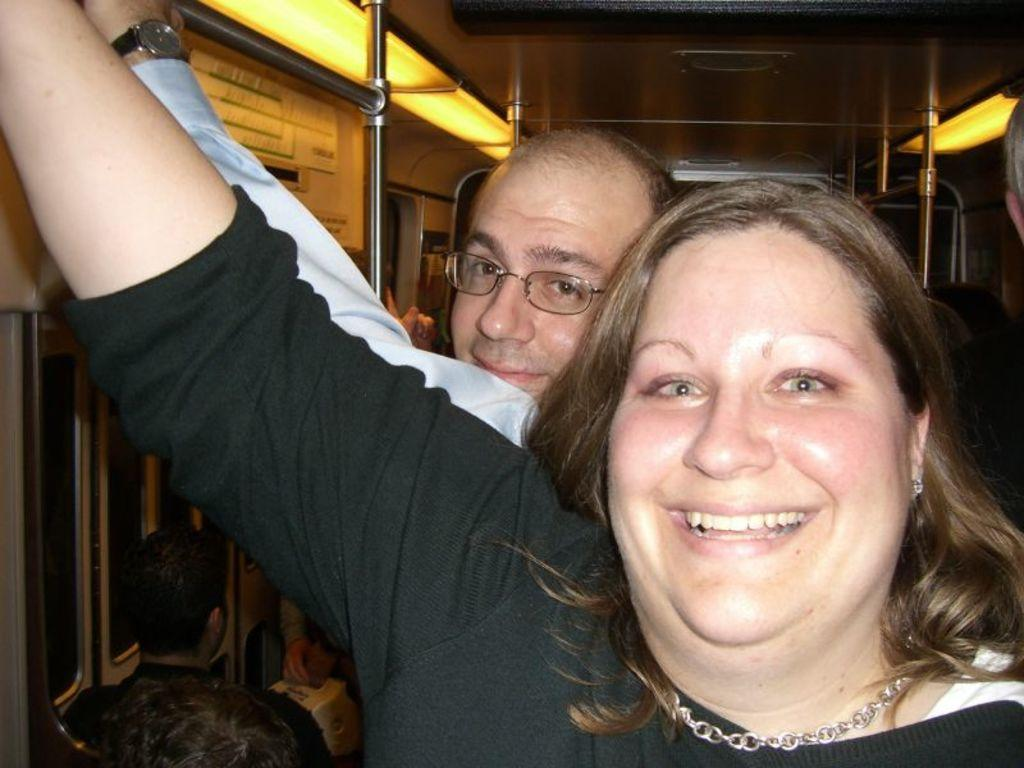What are the two people in the image doing? The two people are standing and holding a metal rod. What can be seen inside the train in the image? There are people sitting on chairs in the train. What type of plate can be seen floating on the lake in the image? There is no plate or lake present in the image; it features two people holding a metal rod and people sitting in a train. 